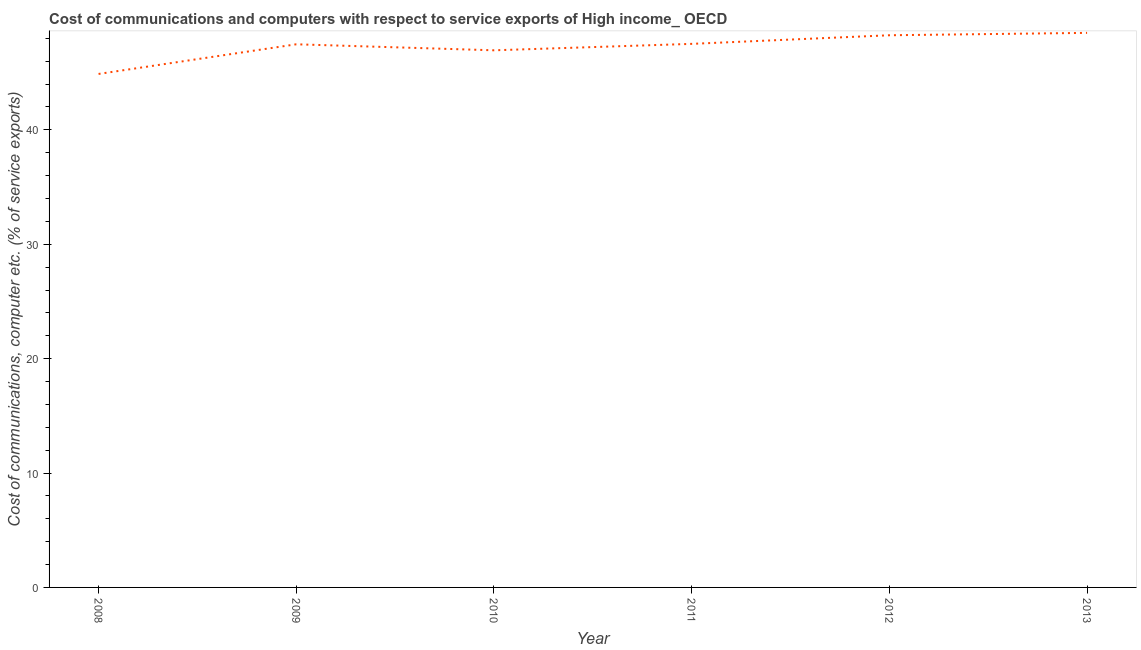What is the cost of communications and computer in 2011?
Make the answer very short. 47.52. Across all years, what is the maximum cost of communications and computer?
Ensure brevity in your answer.  48.48. Across all years, what is the minimum cost of communications and computer?
Your answer should be very brief. 44.89. In which year was the cost of communications and computer minimum?
Your answer should be compact. 2008. What is the sum of the cost of communications and computer?
Give a very brief answer. 283.58. What is the difference between the cost of communications and computer in 2009 and 2012?
Offer a terse response. -0.79. What is the average cost of communications and computer per year?
Offer a very short reply. 47.26. What is the median cost of communications and computer?
Offer a terse response. 47.5. In how many years, is the cost of communications and computer greater than 4 %?
Offer a very short reply. 6. What is the ratio of the cost of communications and computer in 2008 to that in 2013?
Make the answer very short. 0.93. Is the difference between the cost of communications and computer in 2009 and 2010 greater than the difference between any two years?
Provide a succinct answer. No. What is the difference between the highest and the second highest cost of communications and computer?
Your answer should be very brief. 0.21. Is the sum of the cost of communications and computer in 2009 and 2010 greater than the maximum cost of communications and computer across all years?
Your answer should be very brief. Yes. What is the difference between the highest and the lowest cost of communications and computer?
Your answer should be compact. 3.59. How many years are there in the graph?
Your answer should be very brief. 6. Does the graph contain any zero values?
Your answer should be very brief. No. What is the title of the graph?
Your answer should be very brief. Cost of communications and computers with respect to service exports of High income_ OECD. What is the label or title of the X-axis?
Provide a short and direct response. Year. What is the label or title of the Y-axis?
Provide a succinct answer. Cost of communications, computer etc. (% of service exports). What is the Cost of communications, computer etc. (% of service exports) in 2008?
Offer a very short reply. 44.89. What is the Cost of communications, computer etc. (% of service exports) of 2009?
Your answer should be very brief. 47.48. What is the Cost of communications, computer etc. (% of service exports) of 2010?
Offer a very short reply. 46.95. What is the Cost of communications, computer etc. (% of service exports) of 2011?
Provide a succinct answer. 47.52. What is the Cost of communications, computer etc. (% of service exports) of 2012?
Offer a terse response. 48.27. What is the Cost of communications, computer etc. (% of service exports) of 2013?
Your response must be concise. 48.48. What is the difference between the Cost of communications, computer etc. (% of service exports) in 2008 and 2009?
Offer a terse response. -2.59. What is the difference between the Cost of communications, computer etc. (% of service exports) in 2008 and 2010?
Provide a short and direct response. -2.07. What is the difference between the Cost of communications, computer etc. (% of service exports) in 2008 and 2011?
Provide a succinct answer. -2.63. What is the difference between the Cost of communications, computer etc. (% of service exports) in 2008 and 2012?
Keep it short and to the point. -3.38. What is the difference between the Cost of communications, computer etc. (% of service exports) in 2008 and 2013?
Offer a terse response. -3.59. What is the difference between the Cost of communications, computer etc. (% of service exports) in 2009 and 2010?
Your answer should be compact. 0.53. What is the difference between the Cost of communications, computer etc. (% of service exports) in 2009 and 2011?
Keep it short and to the point. -0.04. What is the difference between the Cost of communications, computer etc. (% of service exports) in 2009 and 2012?
Provide a short and direct response. -0.79. What is the difference between the Cost of communications, computer etc. (% of service exports) in 2009 and 2013?
Your response must be concise. -1. What is the difference between the Cost of communications, computer etc. (% of service exports) in 2010 and 2011?
Your answer should be very brief. -0.56. What is the difference between the Cost of communications, computer etc. (% of service exports) in 2010 and 2012?
Provide a short and direct response. -1.32. What is the difference between the Cost of communications, computer etc. (% of service exports) in 2010 and 2013?
Keep it short and to the point. -1.52. What is the difference between the Cost of communications, computer etc. (% of service exports) in 2011 and 2012?
Your response must be concise. -0.75. What is the difference between the Cost of communications, computer etc. (% of service exports) in 2011 and 2013?
Offer a very short reply. -0.96. What is the difference between the Cost of communications, computer etc. (% of service exports) in 2012 and 2013?
Provide a succinct answer. -0.21. What is the ratio of the Cost of communications, computer etc. (% of service exports) in 2008 to that in 2009?
Provide a short and direct response. 0.94. What is the ratio of the Cost of communications, computer etc. (% of service exports) in 2008 to that in 2010?
Your answer should be compact. 0.96. What is the ratio of the Cost of communications, computer etc. (% of service exports) in 2008 to that in 2011?
Your answer should be compact. 0.94. What is the ratio of the Cost of communications, computer etc. (% of service exports) in 2008 to that in 2012?
Offer a very short reply. 0.93. What is the ratio of the Cost of communications, computer etc. (% of service exports) in 2008 to that in 2013?
Give a very brief answer. 0.93. What is the ratio of the Cost of communications, computer etc. (% of service exports) in 2009 to that in 2010?
Offer a very short reply. 1.01. What is the ratio of the Cost of communications, computer etc. (% of service exports) in 2009 to that in 2011?
Offer a terse response. 1. What is the ratio of the Cost of communications, computer etc. (% of service exports) in 2009 to that in 2012?
Offer a very short reply. 0.98. What is the ratio of the Cost of communications, computer etc. (% of service exports) in 2009 to that in 2013?
Give a very brief answer. 0.98. What is the ratio of the Cost of communications, computer etc. (% of service exports) in 2010 to that in 2011?
Offer a terse response. 0.99. What is the ratio of the Cost of communications, computer etc. (% of service exports) in 2010 to that in 2012?
Keep it short and to the point. 0.97. What is the ratio of the Cost of communications, computer etc. (% of service exports) in 2010 to that in 2013?
Keep it short and to the point. 0.97. What is the ratio of the Cost of communications, computer etc. (% of service exports) in 2011 to that in 2012?
Your answer should be compact. 0.98. 